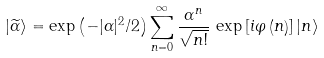Convert formula to latex. <formula><loc_0><loc_0><loc_500><loc_500>| \widetilde { \alpha } \rangle = \exp \left ( - | \alpha | ^ { 2 } / 2 \right ) \sum _ { n = 0 } ^ { \infty } \frac { \alpha ^ { n } } { \sqrt { n ! } } \, \exp \left [ i \varphi \left ( n \right ) \right ] | n \rangle</formula> 